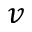Convert formula to latex. <formula><loc_0><loc_0><loc_500><loc_500>v</formula> 